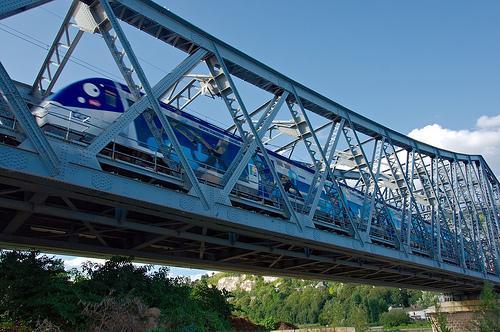How many trains are there?
Give a very brief answer. 1. 